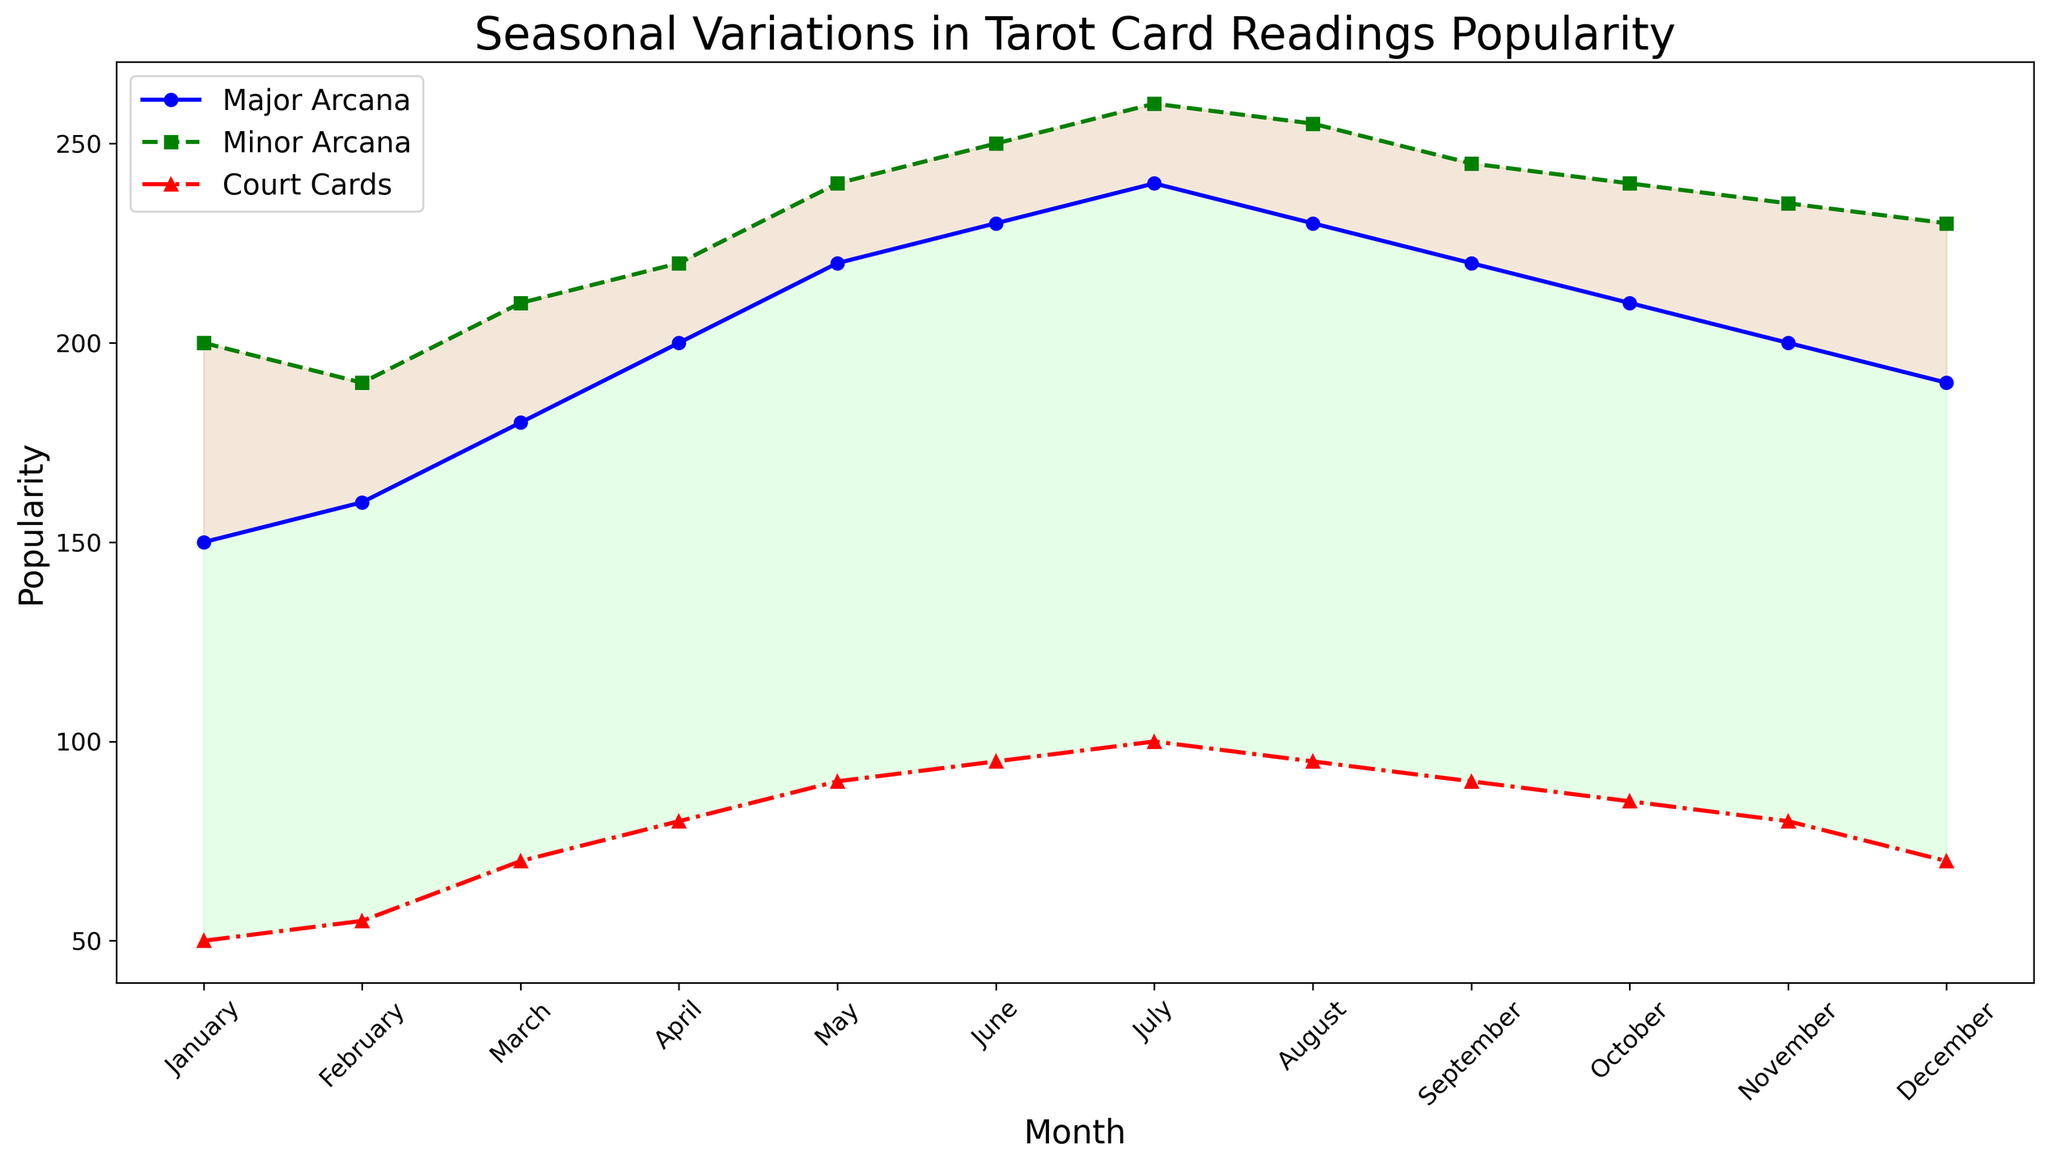What is the difference in the popularity of Major Arcana readings between January and July? To find the difference in popularity, subtract the January value from the July value for Major Arcana. The January value is 150, and the July value is 240. Thus, the difference is 240 - 150 = 90.
Answer: 90 Which type of tarot card reading has the highest popularity in August? In August, the popularity values are 230 for Major Arcana, 255 for Minor Arcana, and 95 for Court Cards. The highest value among these is 255, which corresponds to Minor Arcana.
Answer: Minor Arcana How many months is the popularity of Court Cards higher than 90? By observing the plot, the months with Court Cards popularity higher than 90 are June, July, and August. That's 3 months.
Answer: 3 What is the average popularity of Minor Arcana readings from January to June? To find the average, sum the popularity values for January (200), February (190), March (210), April (220), May (240), and June (250), and then divide by the number of months: (200 + 190 + 210 + 220 + 240 + 250) / 6 = 1310 / 6 = 218.33.
Answer: 218.33 In which month do Major Arcana readings have their peak popularity? By examining the plot, the highest point for Major Arcana is in July with a value of 240.
Answer: July Which month shows the smallest difference between the popularity of Major Arcana and Minor Arcana readings? Calculate the differences for each month and compare them. The differences are January (50), February (30), March (30), April (20), May (20), June (20), July (20), August (25), September (25), October (30), November (35), December (40). The smallest difference is in April, May, June, and July, all of which are 20.
Answer: April, May, June, July Between which two consecutive months is the change in popularity for Court Cards the largest? Calculate the changes for each consecutive month pair: January-February (5), February-March (15), March-April (10), April-May (10), May-June (5), June-July (5), July-August (5), August-September (5), September-October (5), October-November (5), November-December (10). The largest change is between February and March, which is 15.
Answer: February-March Are there any months where all types of tarot card readings have shown an equal increase in popularity compared to the previous month? Check consecutive month pairs to see if all three types of readings have increased by the same amount compared to the previous month. No such pattern is observed in the data.
Answer: No 